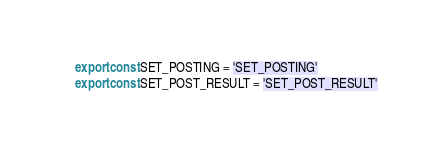Convert code to text. <code><loc_0><loc_0><loc_500><loc_500><_JavaScript_>export const SET_POSTING = 'SET_POSTING'
export const SET_POST_RESULT = 'SET_POST_RESULT'
</code> 